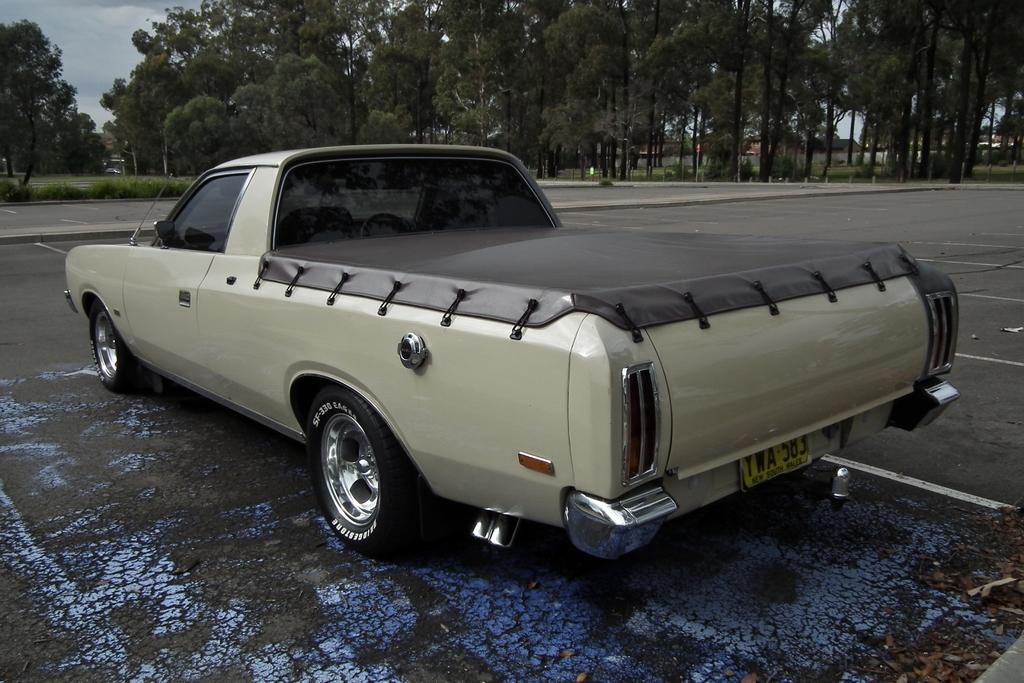What is the main subject of the image? The main subject of the image is a car. Can you describe the car's appearance? The car is cream-colored. What is at the bottom of the image? There is a road at the bottom of the image. What can be seen in the background of the image? There are trees in the background of the image. What is visible in the sky at the top of the image? There are clouds visible in the sky at the top of the image. What type of flame can be seen coming from the car's exhaust in the image? There is no flame coming from the car's exhaust in the image; it is not visible. How does the car attract the attention of passersby in the image? The car's appearance and the image itself do not indicate any specific actions to attract attention. 